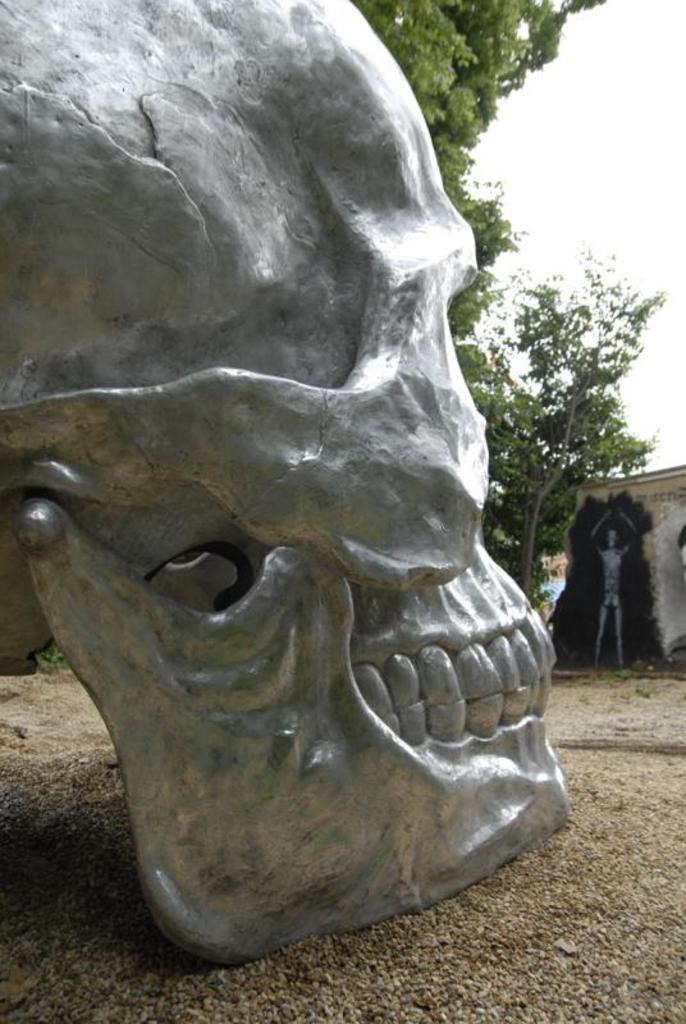In one or two sentences, can you explain what this image depicts? In the image there is a skull statue on the land with trees behind it. 